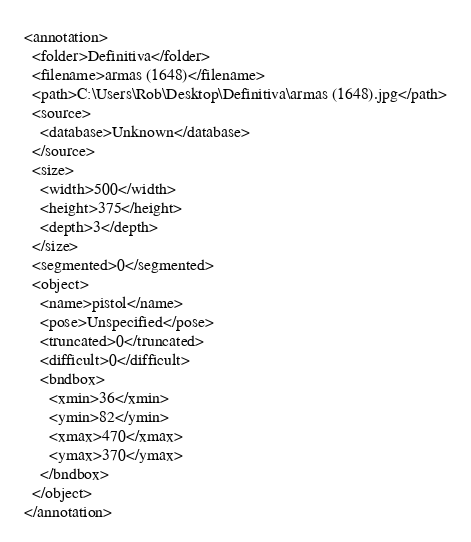Convert code to text. <code><loc_0><loc_0><loc_500><loc_500><_XML_><annotation>
  <folder>Definitiva</folder>
  <filename>armas (1648)</filename>
  <path>C:\Users\Rob\Desktop\Definitiva\armas (1648).jpg</path>
  <source>
    <database>Unknown</database>
  </source>
  <size>
    <width>500</width>
    <height>375</height>
    <depth>3</depth>
  </size>
  <segmented>0</segmented>
  <object>
    <name>pistol</name>
    <pose>Unspecified</pose>
    <truncated>0</truncated>
    <difficult>0</difficult>
    <bndbox>
      <xmin>36</xmin>
      <ymin>82</ymin>
      <xmax>470</xmax>
      <ymax>370</ymax>
    </bndbox>
  </object>
</annotation>
</code> 